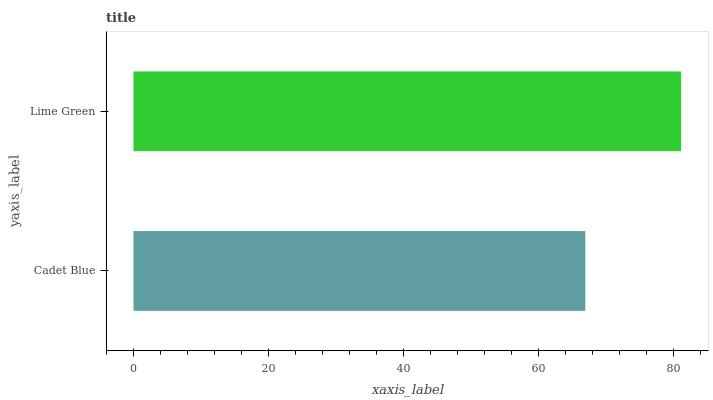Is Cadet Blue the minimum?
Answer yes or no. Yes. Is Lime Green the maximum?
Answer yes or no. Yes. Is Lime Green the minimum?
Answer yes or no. No. Is Lime Green greater than Cadet Blue?
Answer yes or no. Yes. Is Cadet Blue less than Lime Green?
Answer yes or no. Yes. Is Cadet Blue greater than Lime Green?
Answer yes or no. No. Is Lime Green less than Cadet Blue?
Answer yes or no. No. Is Lime Green the high median?
Answer yes or no. Yes. Is Cadet Blue the low median?
Answer yes or no. Yes. Is Cadet Blue the high median?
Answer yes or no. No. Is Lime Green the low median?
Answer yes or no. No. 